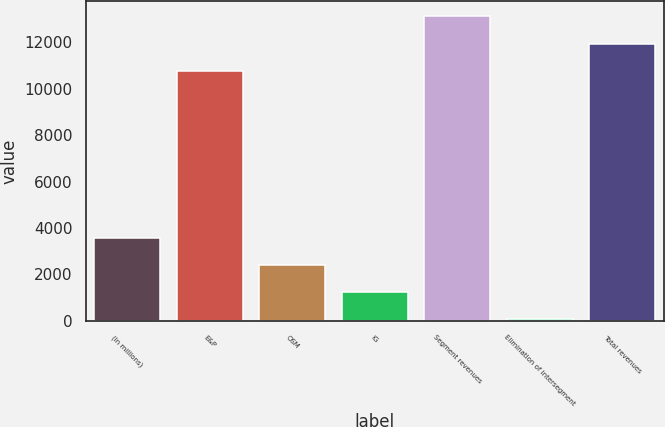<chart> <loc_0><loc_0><loc_500><loc_500><bar_chart><fcel>(In millions)<fcel>E&P<fcel>OSM<fcel>IG<fcel>Segment revenues<fcel>Elimination of intersegment<fcel>Total revenues<nl><fcel>3582<fcel>10782<fcel>2413<fcel>1244<fcel>13120<fcel>75<fcel>11951<nl></chart> 